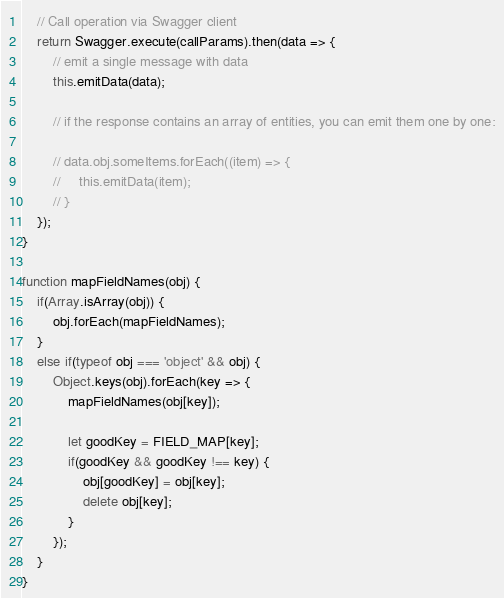<code> <loc_0><loc_0><loc_500><loc_500><_JavaScript_>    // Call operation via Swagger client
    return Swagger.execute(callParams).then(data => {
        // emit a single message with data
        this.emitData(data);

        // if the response contains an array of entities, you can emit them one by one:

        // data.obj.someItems.forEach((item) => {
        //     this.emitData(item);
        // }
    });
}

function mapFieldNames(obj) {
    if(Array.isArray(obj)) {
        obj.forEach(mapFieldNames);
    }
    else if(typeof obj === 'object' && obj) {
        Object.keys(obj).forEach(key => {
            mapFieldNames(obj[key]);

            let goodKey = FIELD_MAP[key];
            if(goodKey && goodKey !== key) {
                obj[goodKey] = obj[key];
                delete obj[key];
            }
        });
    }
}</code> 